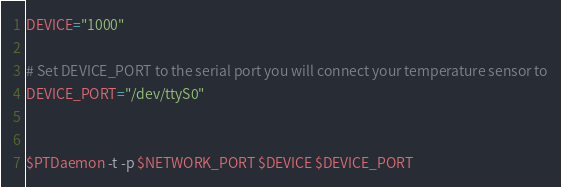<code> <loc_0><loc_0><loc_500><loc_500><_Bash_>DEVICE="1000"

# Set DEVICE_PORT to the serial port you will connect your temperature sensor to
DEVICE_PORT="/dev/ttyS0"


$PTDaemon -t -p $NETWORK_PORT $DEVICE $DEVICE_PORT
</code> 